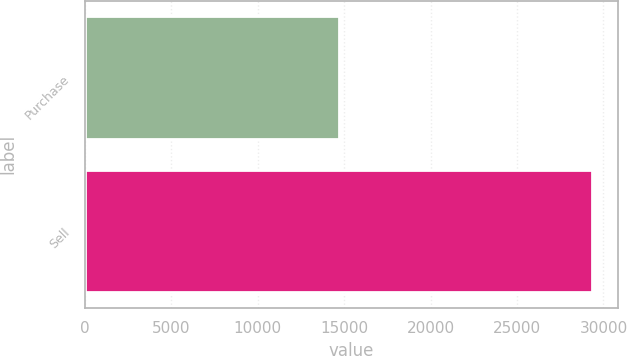Convert chart. <chart><loc_0><loc_0><loc_500><loc_500><bar_chart><fcel>Purchase<fcel>Sell<nl><fcel>14689<fcel>29362<nl></chart> 